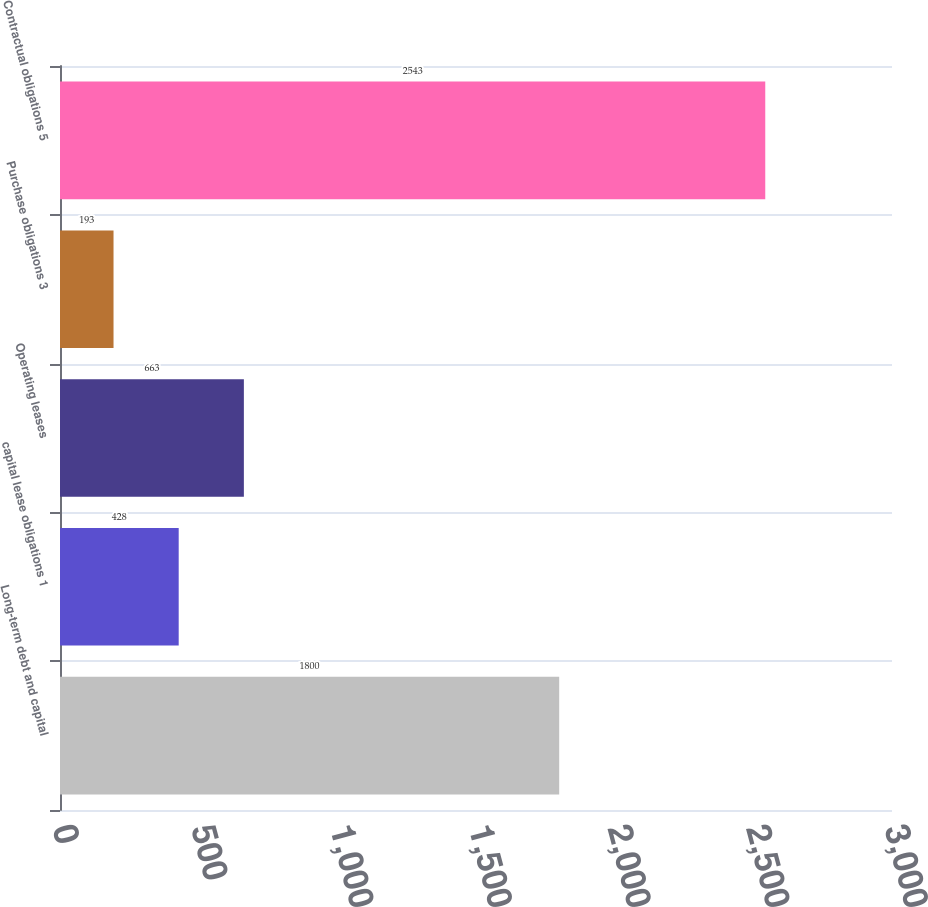Convert chart to OTSL. <chart><loc_0><loc_0><loc_500><loc_500><bar_chart><fcel>Long-term debt and capital<fcel>capital lease obligations 1<fcel>Operating leases<fcel>Purchase obligations 3<fcel>Contractual obligations 5<nl><fcel>1800<fcel>428<fcel>663<fcel>193<fcel>2543<nl></chart> 